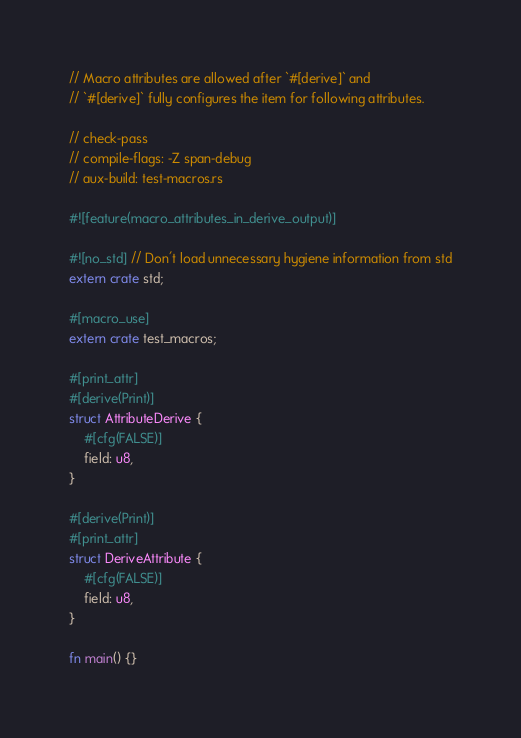<code> <loc_0><loc_0><loc_500><loc_500><_Rust_>// Macro attributes are allowed after `#[derive]` and
// `#[derive]` fully configures the item for following attributes.

// check-pass
// compile-flags: -Z span-debug
// aux-build: test-macros.rs

#![feature(macro_attributes_in_derive_output)]

#![no_std] // Don't load unnecessary hygiene information from std
extern crate std;

#[macro_use]
extern crate test_macros;

#[print_attr]
#[derive(Print)]
struct AttributeDerive {
    #[cfg(FALSE)]
    field: u8,
}

#[derive(Print)]
#[print_attr]
struct DeriveAttribute {
    #[cfg(FALSE)]
    field: u8,
}

fn main() {}
</code> 